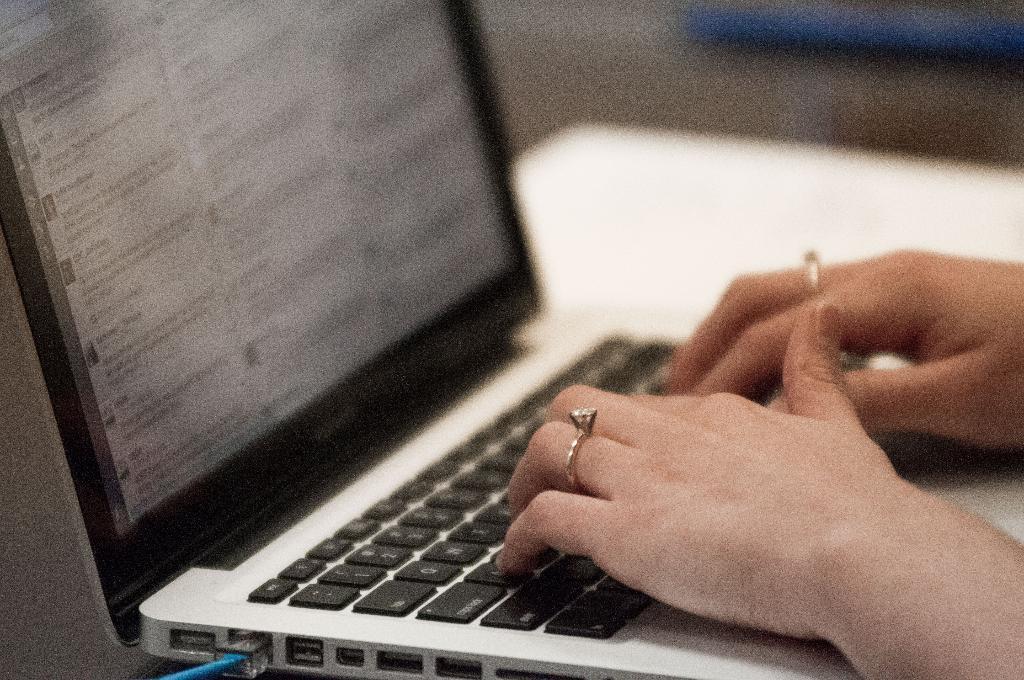What key is above and to the left of the"q" key?
Offer a very short reply. 1. 